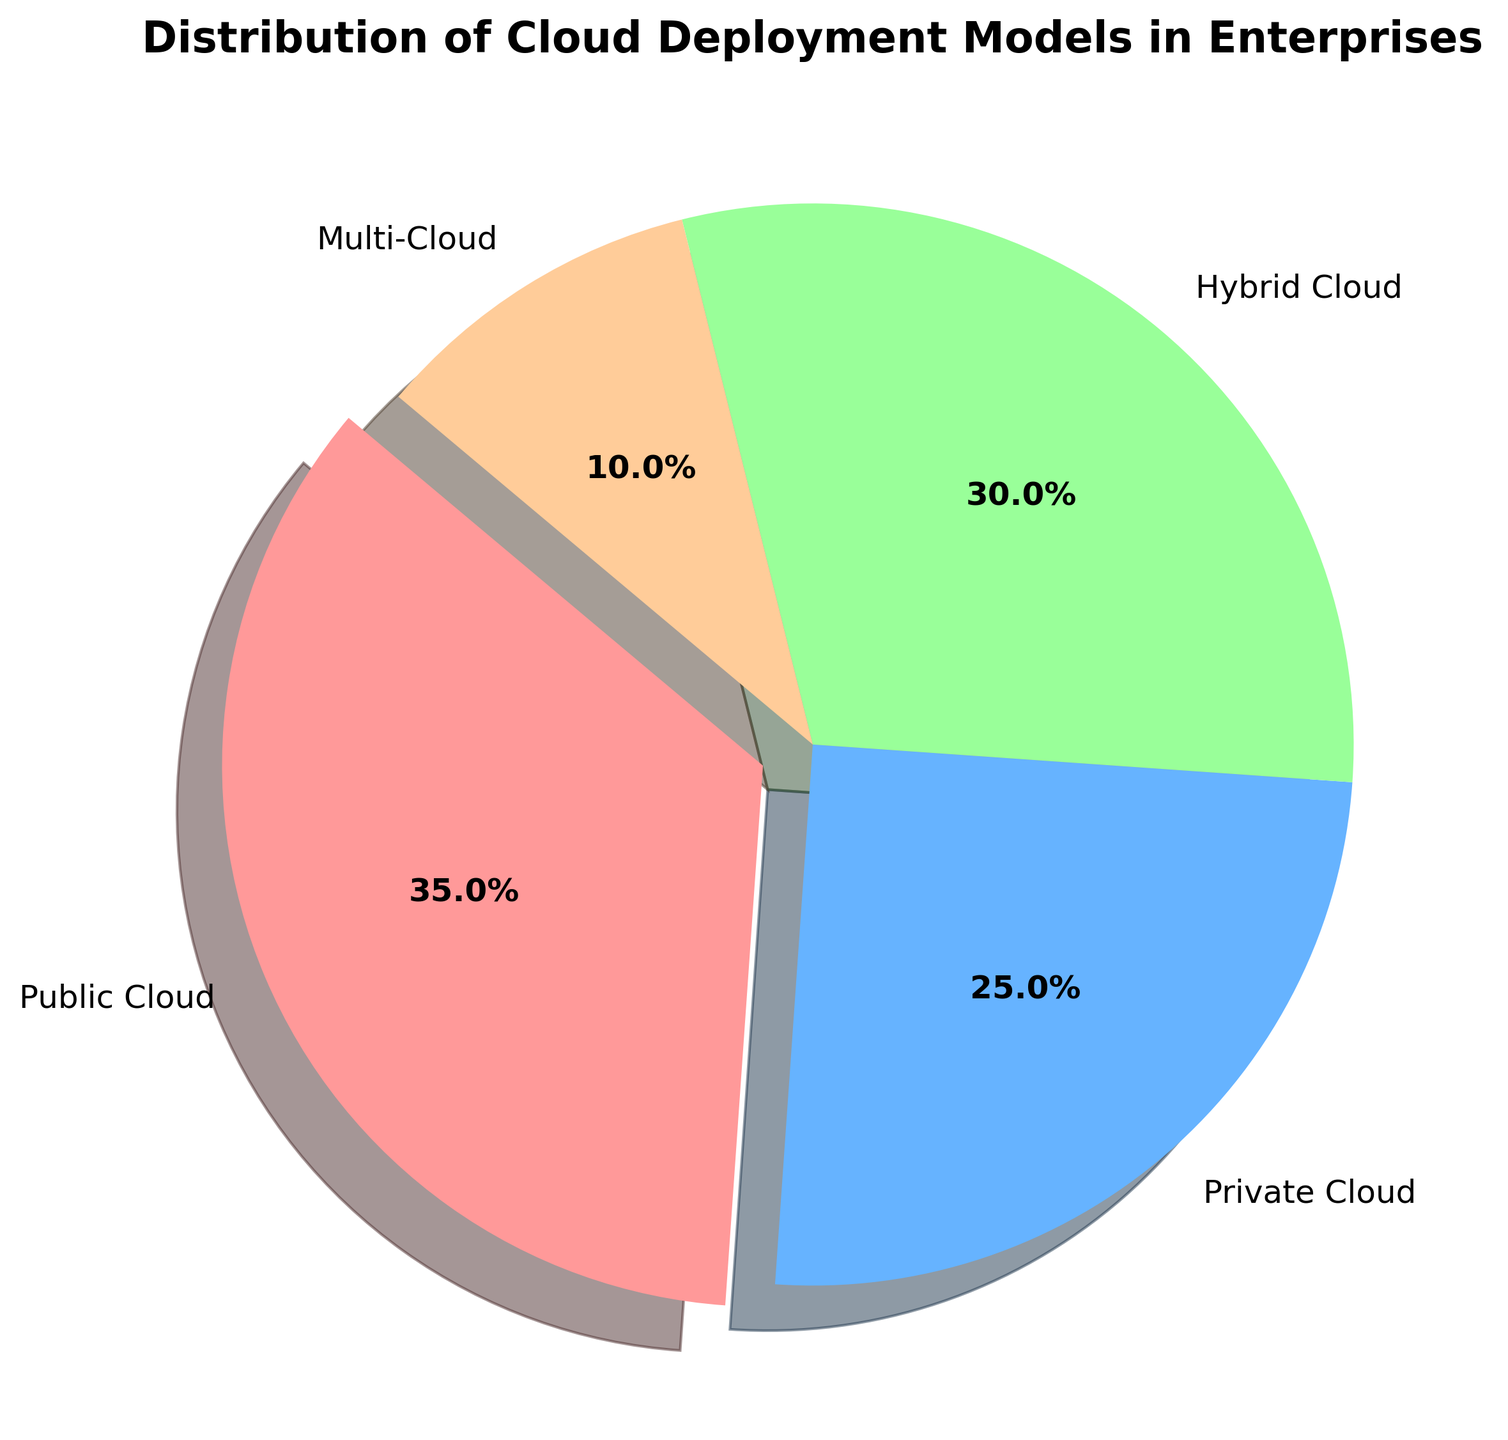what is the percentage of enterprises using Public Cloud? Look at the "Public Cloud" segment in the pie chart and note the percentage value displayed within or adjacent to it. The figure directly shows the percentage.
Answer: 35% Which cloud deployment model is the least used in enterprises? Identify the segment with the smallest percentage in the pie chart. The segment with the smallest portion is labeled "Multi-Cloud" with 10%.
Answer: Multi-Cloud How much more prevalent is Public Cloud compared to Multi-Cloud? Subtract the percentage of Multi-Cloud from that of Public Cloud: 35% - 10% = 25%.
Answer: 25% Is Hybrid Cloud more prevalent than Private Cloud? Compare the percentage values of Hybrid Cloud and Private Cloud in the pie chart. Hybrid Cloud (30%) is indeed more prevalent than Private Cloud (25%).
Answer: Yes What percentage of enterprises use either Hybrid Cloud or Private Cloud? Sum the percentages for Hybrid Cloud and Private Cloud: 30% + 25% = 55%.
Answer: 55% What color is used to represent Private Cloud in the pie chart? Locate the segment labeled "Private Cloud" and observe its color. The segment is represented in light blue.
Answer: Light blue Which two cloud deployment models together cover less than 50% of enterprises? Identify segments where the combined percentages are less than 50%. Multi-Cloud (10%) and Private Cloud (25%) together account for only 35%, which is less than 50%.
Answer: Multi-Cloud and Private Cloud Between Public Cloud and Hybrid Cloud, which one has a larger share, and by how much? Compare their percentages: Public Cloud (35%) and Hybrid Cloud (30%). The difference is: 35% - 30% = 5%.
Answer: Public Cloud by 5% What fraction of the pie chart does the Multi-Cloud segment represent? Convert the percentage of Multi-Cloud to a fraction. Multi-Cloud is 10%, which is 10/100 or 1/10.
Answer: 1/10 